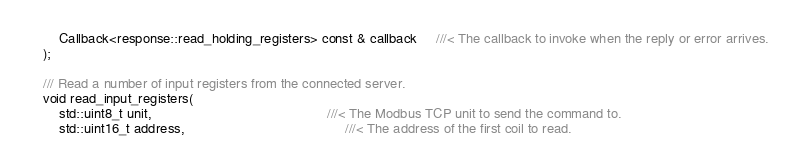Convert code to text. <code><loc_0><loc_0><loc_500><loc_500><_C++_>		Callback<response::read_holding_registers> const & callback     ///< The callback to invoke when the reply or error arrives.
	);

	/// Read a number of input registers from the connected server.
	void read_input_registers(
		std::uint8_t unit,                                              ///< The Modbus TCP unit to send the command to.
		std::uint16_t address,                                          ///< The address of the first coil to read.</code> 